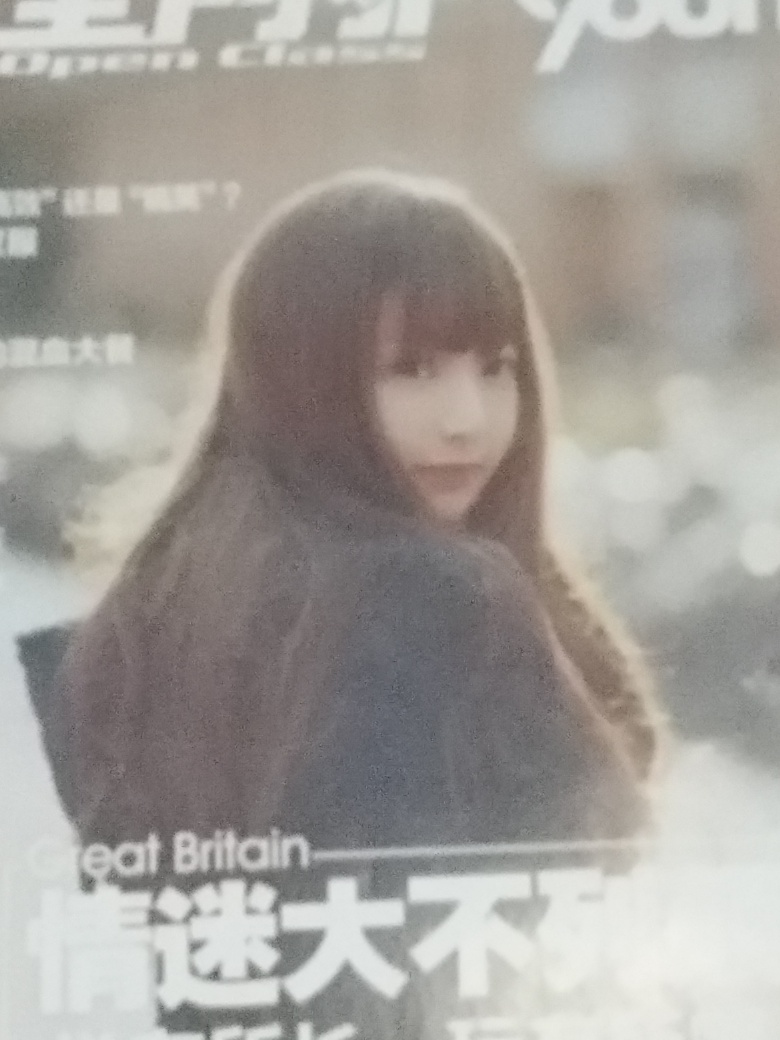Delve into the quality of the photograph and give a verdict based on your scrutiny. Upon careful observation, the photograph exhibits artistic character despite technical imperfections. The soft focus and notable grain contribute to a dreamy, ethereal atmosphere, possibly desired by the photographer. While the fine details are lost and the colors are muted, this stylistic choice can evoke a sense of nostalgia or emotionality. The subject is centrally composed, giving a straightforward portrayal, yet the background blur successfully isolates the subject, generating a sense of intimacy. Although it might not meet conventional criteria for high-definition clarity, the image does possess a certain charm that speaks to the subject's presence and the mood conveyed. 